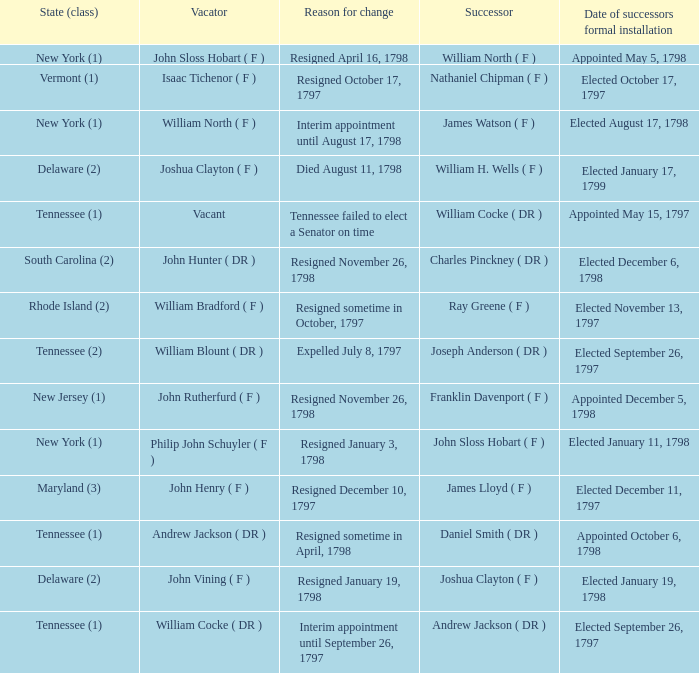What is the total number of dates of successor formal installation when the vacator was Joshua Clayton ( F )? 1.0. 